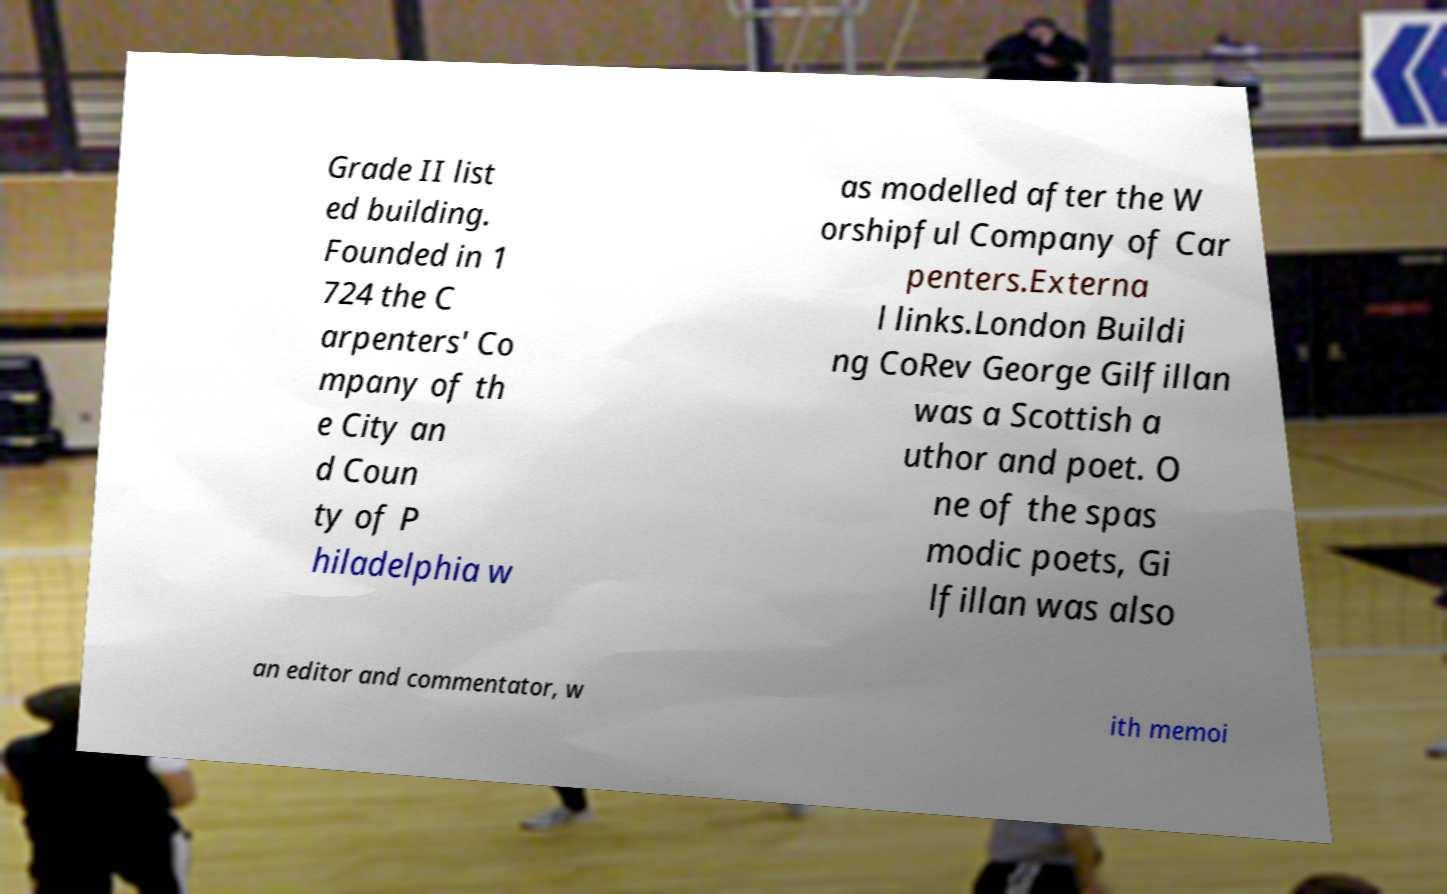Please identify and transcribe the text found in this image. Grade II list ed building. Founded in 1 724 the C arpenters' Co mpany of th e City an d Coun ty of P hiladelphia w as modelled after the W orshipful Company of Car penters.Externa l links.London Buildi ng CoRev George Gilfillan was a Scottish a uthor and poet. O ne of the spas modic poets, Gi lfillan was also an editor and commentator, w ith memoi 